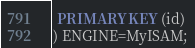Convert code to text. <code><loc_0><loc_0><loc_500><loc_500><_SQL_> PRIMARY KEY (id)
) ENGINE=MyISAM;
</code> 